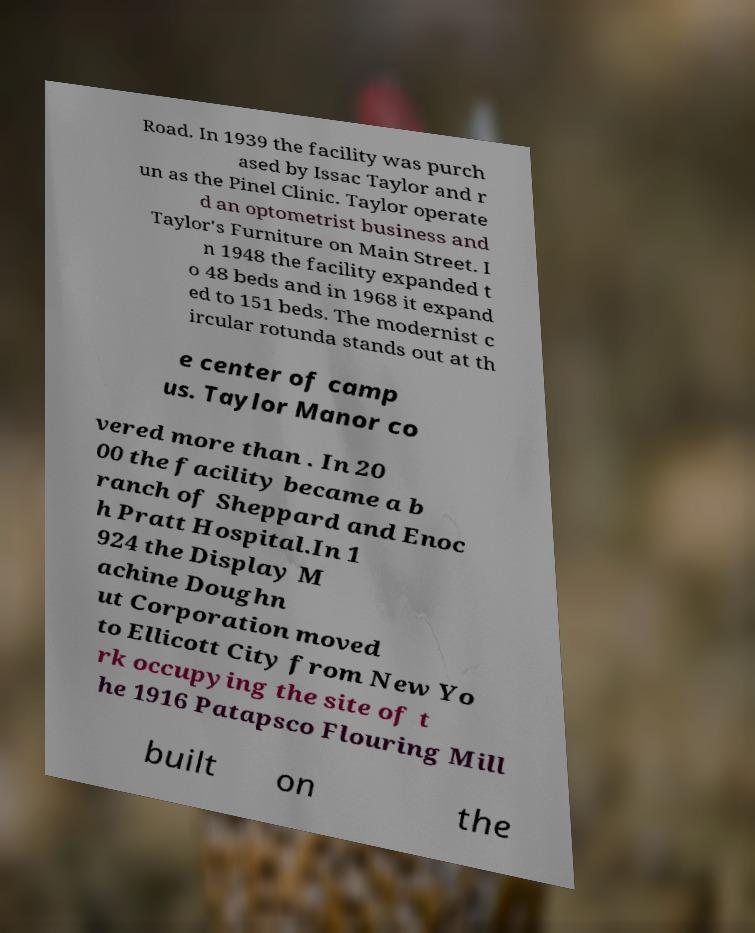Could you assist in decoding the text presented in this image and type it out clearly? Road. In 1939 the facility was purch ased by Issac Taylor and r un as the Pinel Clinic. Taylor operate d an optometrist business and Taylor's Furniture on Main Street. I n 1948 the facility expanded t o 48 beds and in 1968 it expand ed to 151 beds. The modernist c ircular rotunda stands out at th e center of camp us. Taylor Manor co vered more than . In 20 00 the facility became a b ranch of Sheppard and Enoc h Pratt Hospital.In 1 924 the Display M achine Doughn ut Corporation moved to Ellicott City from New Yo rk occupying the site of t he 1916 Patapsco Flouring Mill built on the 